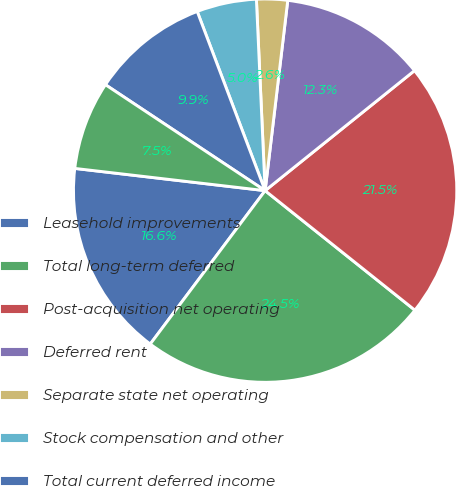Convert chart. <chart><loc_0><loc_0><loc_500><loc_500><pie_chart><fcel>Leasehold improvements<fcel>Total long-term deferred<fcel>Post-acquisition net operating<fcel>Deferred rent<fcel>Separate state net operating<fcel>Stock compensation and other<fcel>Total current deferred income<fcel>Allowances reserves and other<nl><fcel>16.62%<fcel>24.51%<fcel>21.49%<fcel>12.34%<fcel>2.61%<fcel>5.04%<fcel>9.91%<fcel>7.47%<nl></chart> 